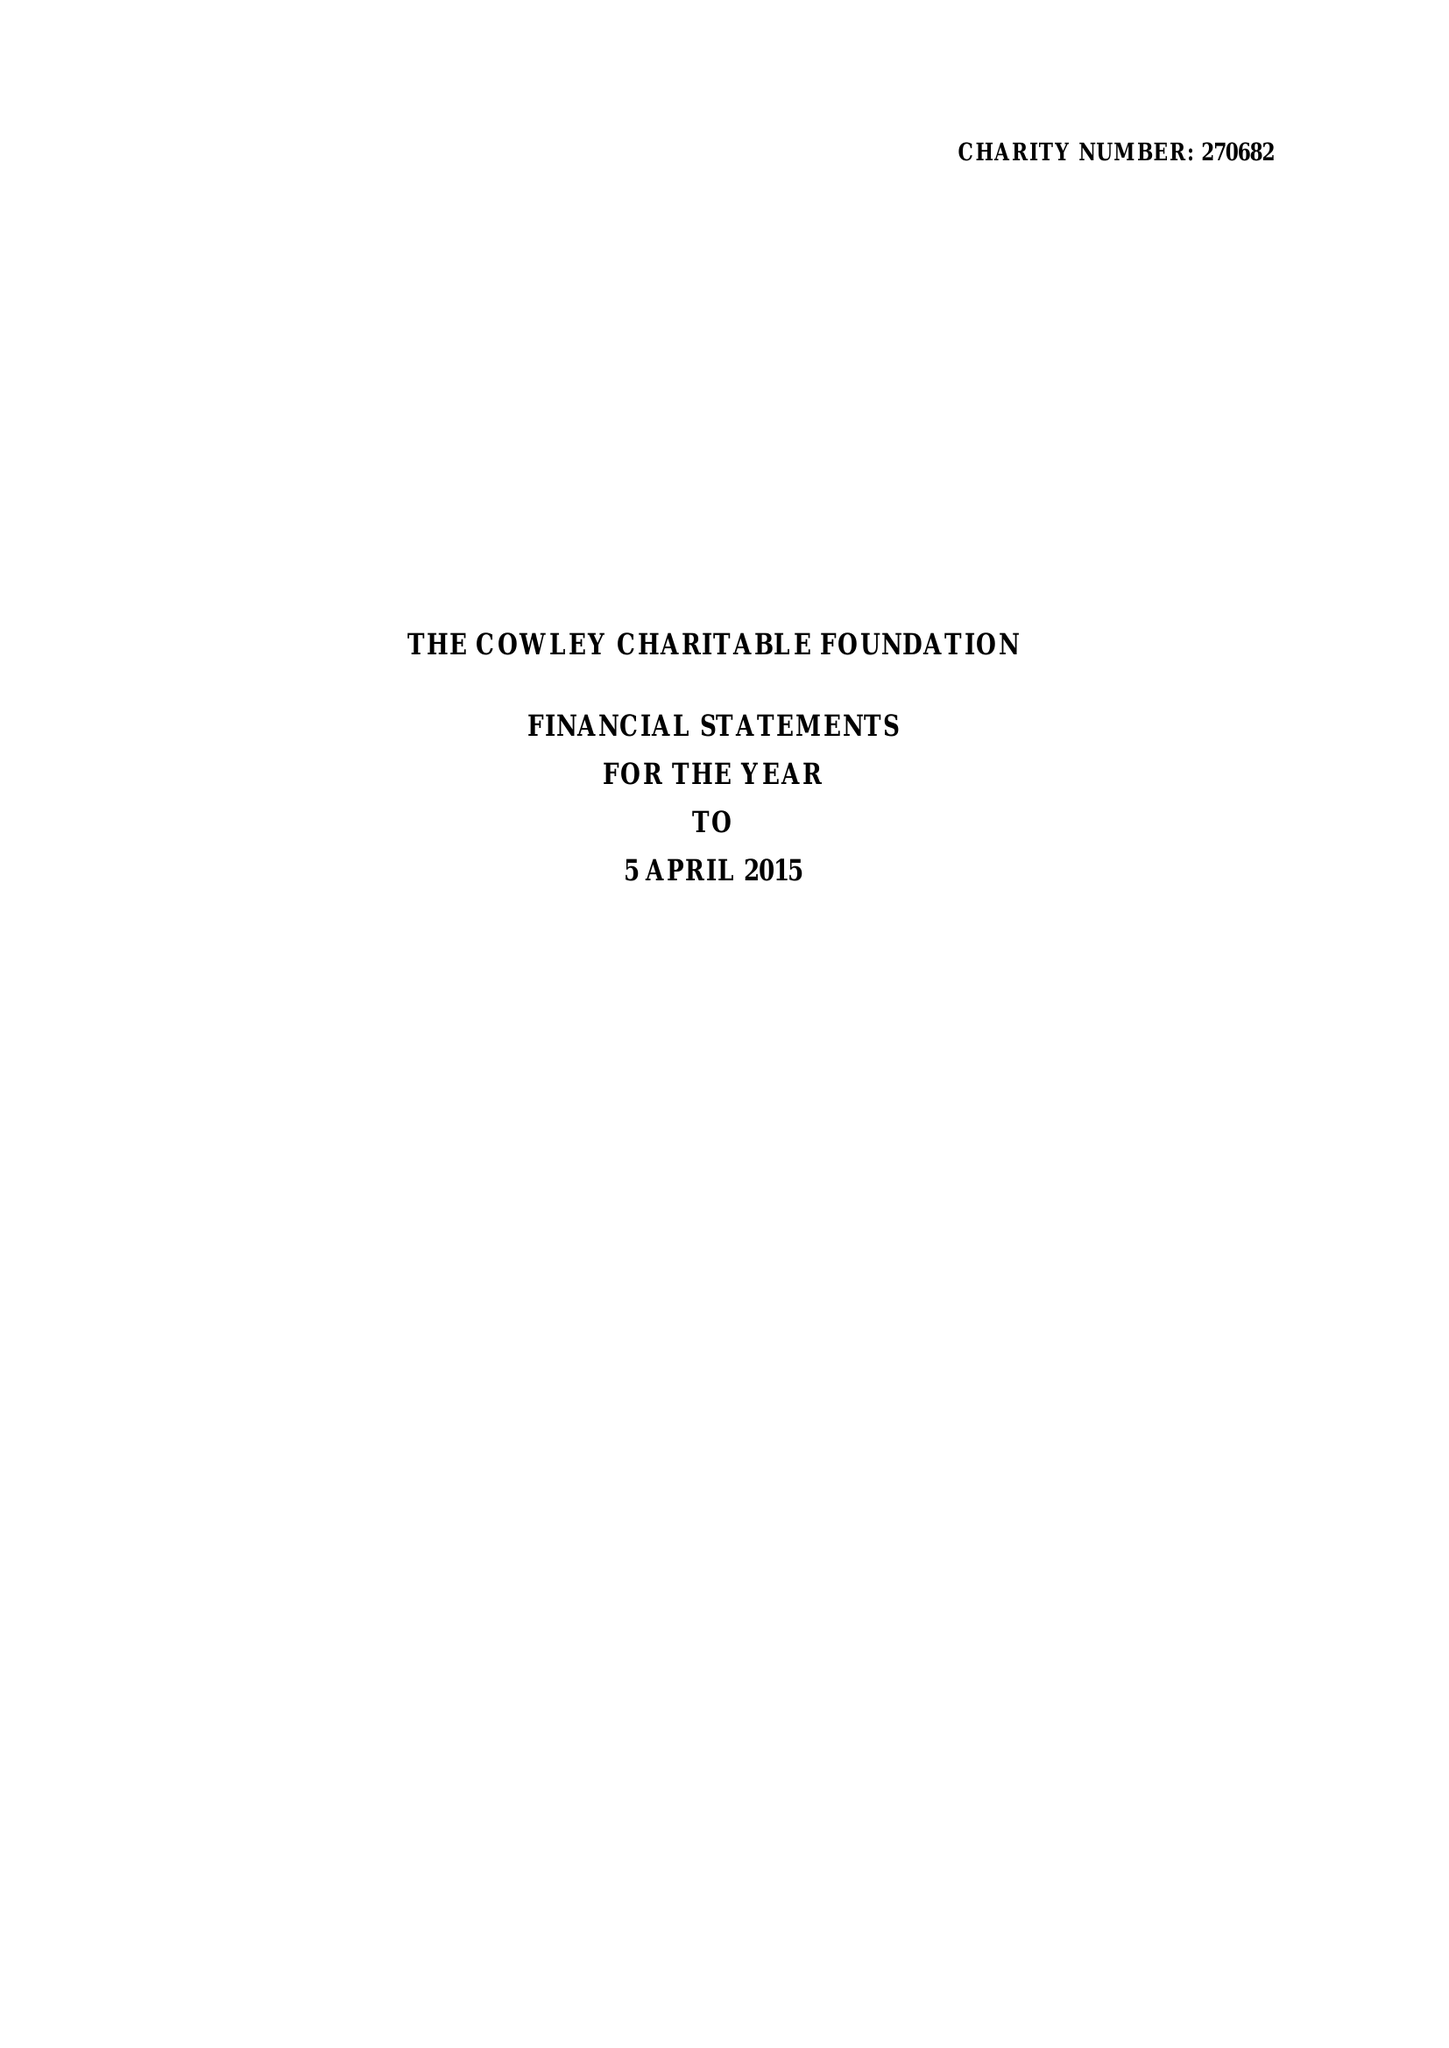What is the value for the address__street_line?
Answer the question using a single word or phrase. 17 GROSVENOR GARDENS 